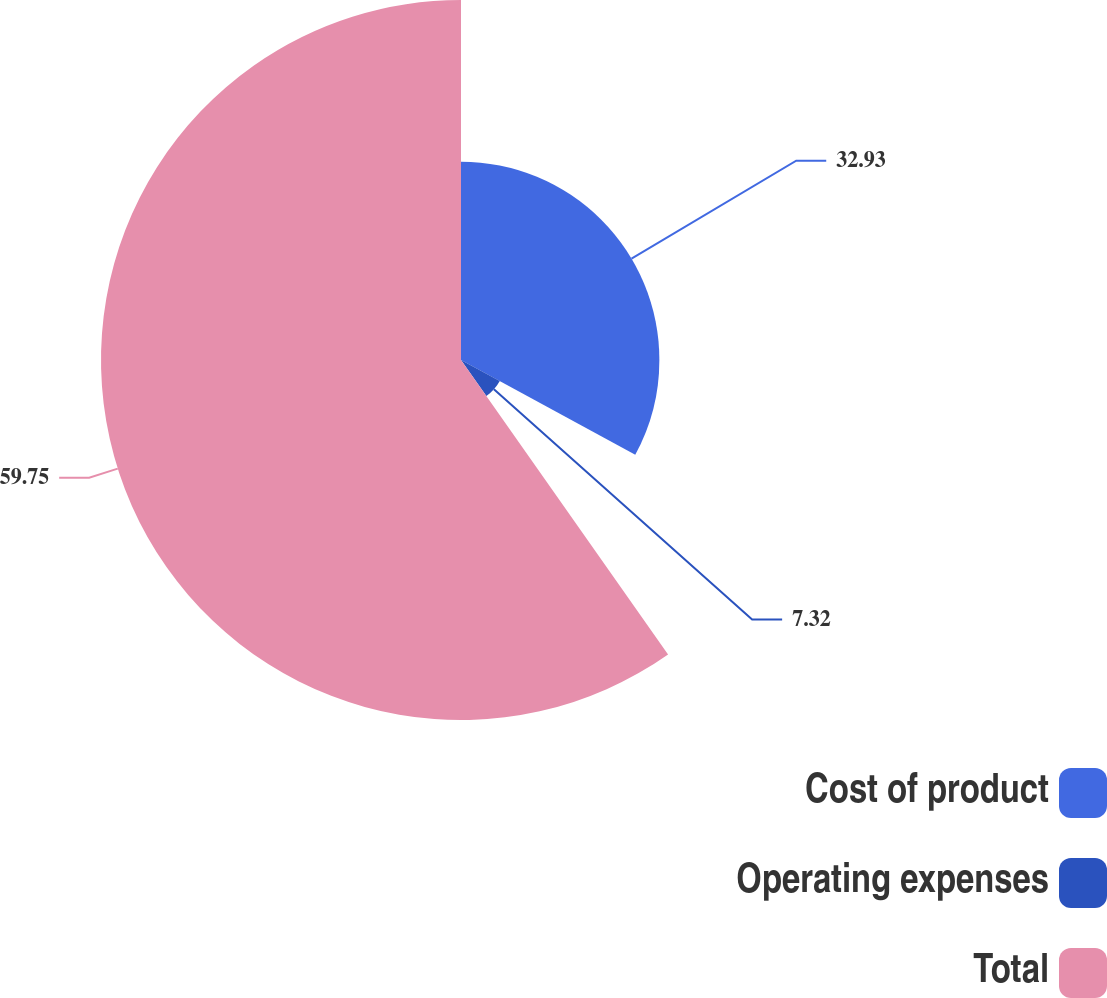Convert chart. <chart><loc_0><loc_0><loc_500><loc_500><pie_chart><fcel>Cost of product<fcel>Operating expenses<fcel>Total<nl><fcel>32.93%<fcel>7.32%<fcel>59.76%<nl></chart> 